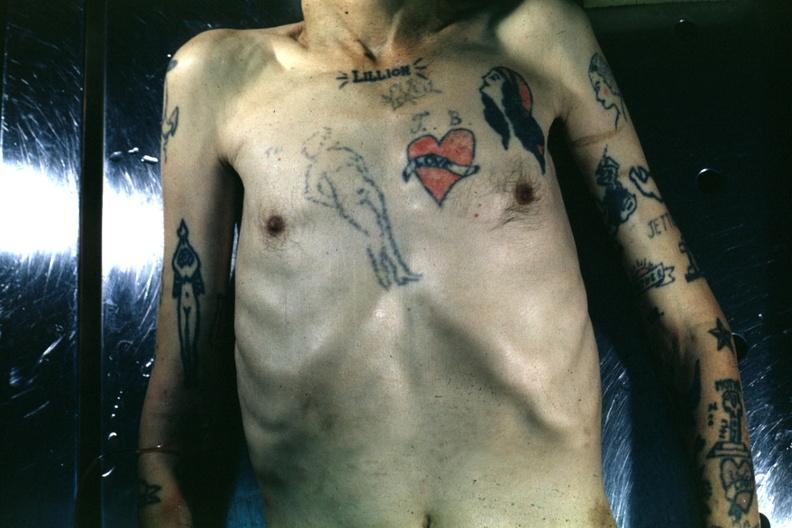where is this?
Answer the question using a single word or phrase. Skin 